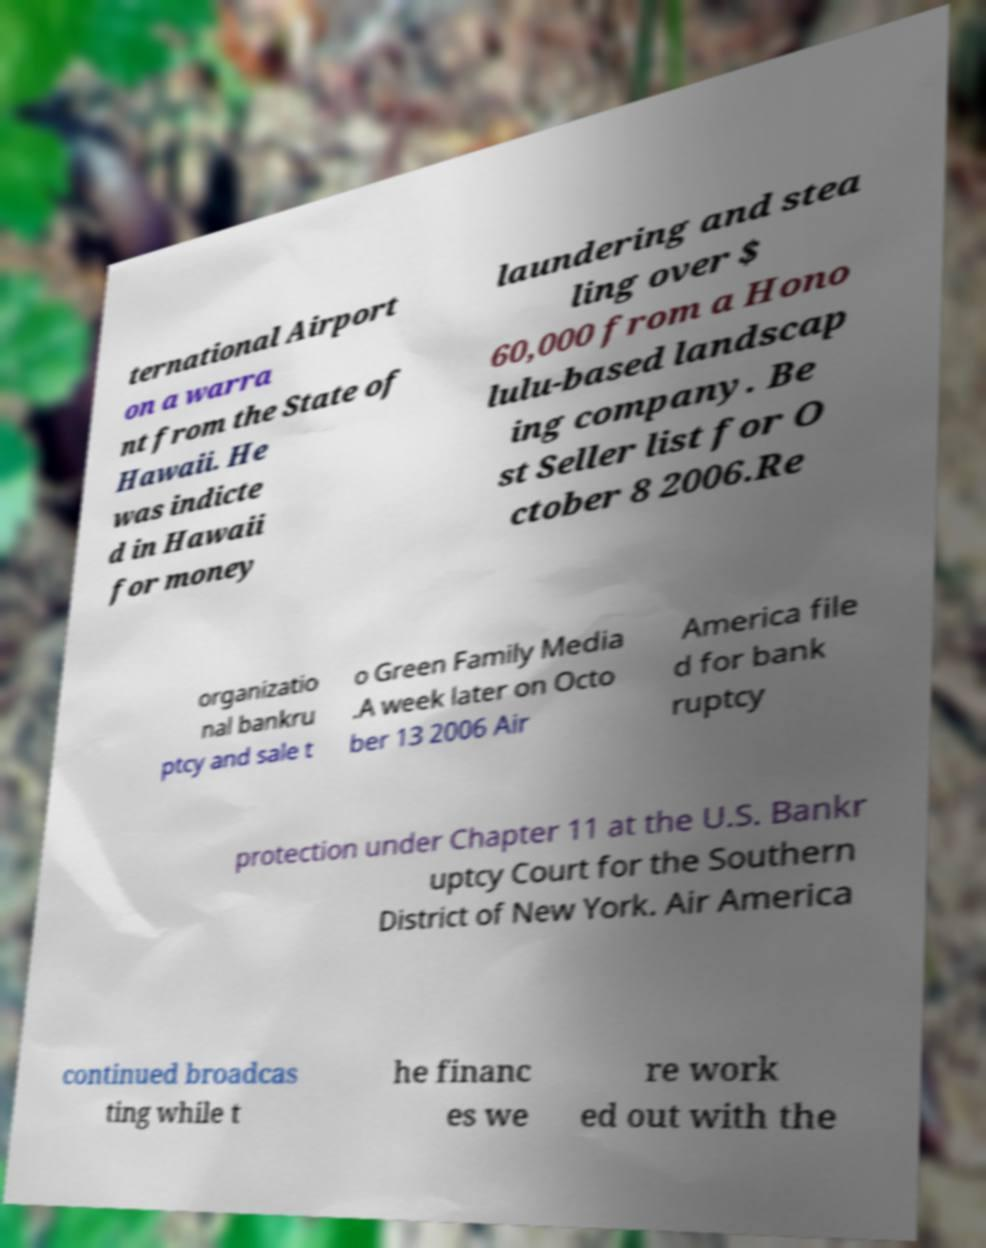Could you extract and type out the text from this image? ternational Airport on a warra nt from the State of Hawaii. He was indicte d in Hawaii for money laundering and stea ling over $ 60,000 from a Hono lulu-based landscap ing company. Be st Seller list for O ctober 8 2006.Re organizatio nal bankru ptcy and sale t o Green Family Media .A week later on Octo ber 13 2006 Air America file d for bank ruptcy protection under Chapter 11 at the U.S. Bankr uptcy Court for the Southern District of New York. Air America continued broadcas ting while t he financ es we re work ed out with the 